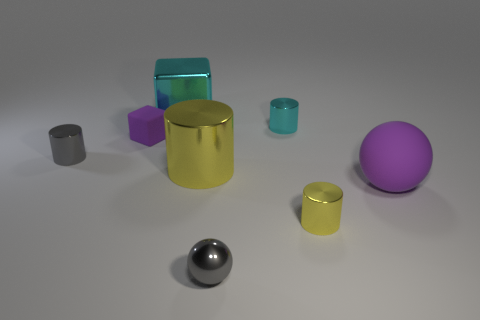What material is the yellow cylinder that is left of the ball left of the purple matte sphere?
Your response must be concise. Metal. What is the gray object to the left of the big cyan thing made of?
Make the answer very short. Metal. How many large matte objects are the same shape as the small cyan thing?
Your answer should be very brief. 0. Is the large cylinder the same color as the shiny cube?
Provide a short and direct response. No. What material is the block that is behind the block that is to the left of the cube to the right of the rubber block made of?
Your response must be concise. Metal. There is a cyan cylinder; are there any large objects behind it?
Ensure brevity in your answer.  Yes. There is a yellow metal thing that is the same size as the purple ball; what is its shape?
Your response must be concise. Cylinder. Does the large cyan object have the same material as the big purple object?
Give a very brief answer. No. What number of matte objects are large red things or tiny blocks?
Offer a terse response. 1. The rubber thing that is the same color as the matte sphere is what shape?
Offer a terse response. Cube. 